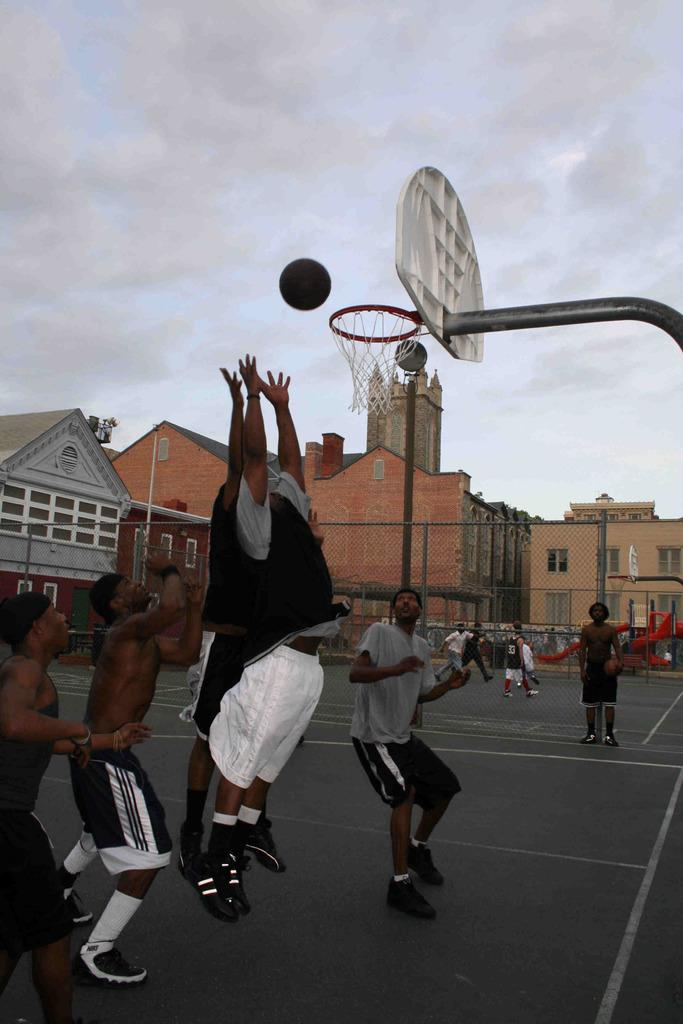What are the people in the image doing? The people in the image are playing in the ground. What surrounds the area where the people are playing? There is a fence around the ground. What can be seen on the other side of the fence? There are buildings visible on the other side of the fence. How many giants are playing with the people in the image? There are no giants present in the image; only people are playing in the ground. 